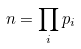<formula> <loc_0><loc_0><loc_500><loc_500>n = \prod _ { i } p _ { i }</formula> 